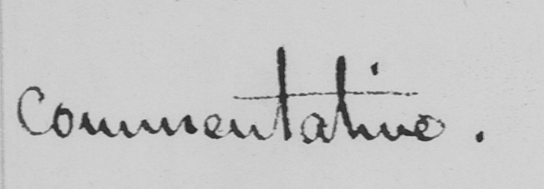Please provide the text content of this handwritten line. commentative . 